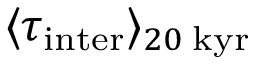<formula> <loc_0><loc_0><loc_500><loc_500>\langle \tau _ { i n t e r } \rangle _ { 2 0 \, k y r }</formula> 